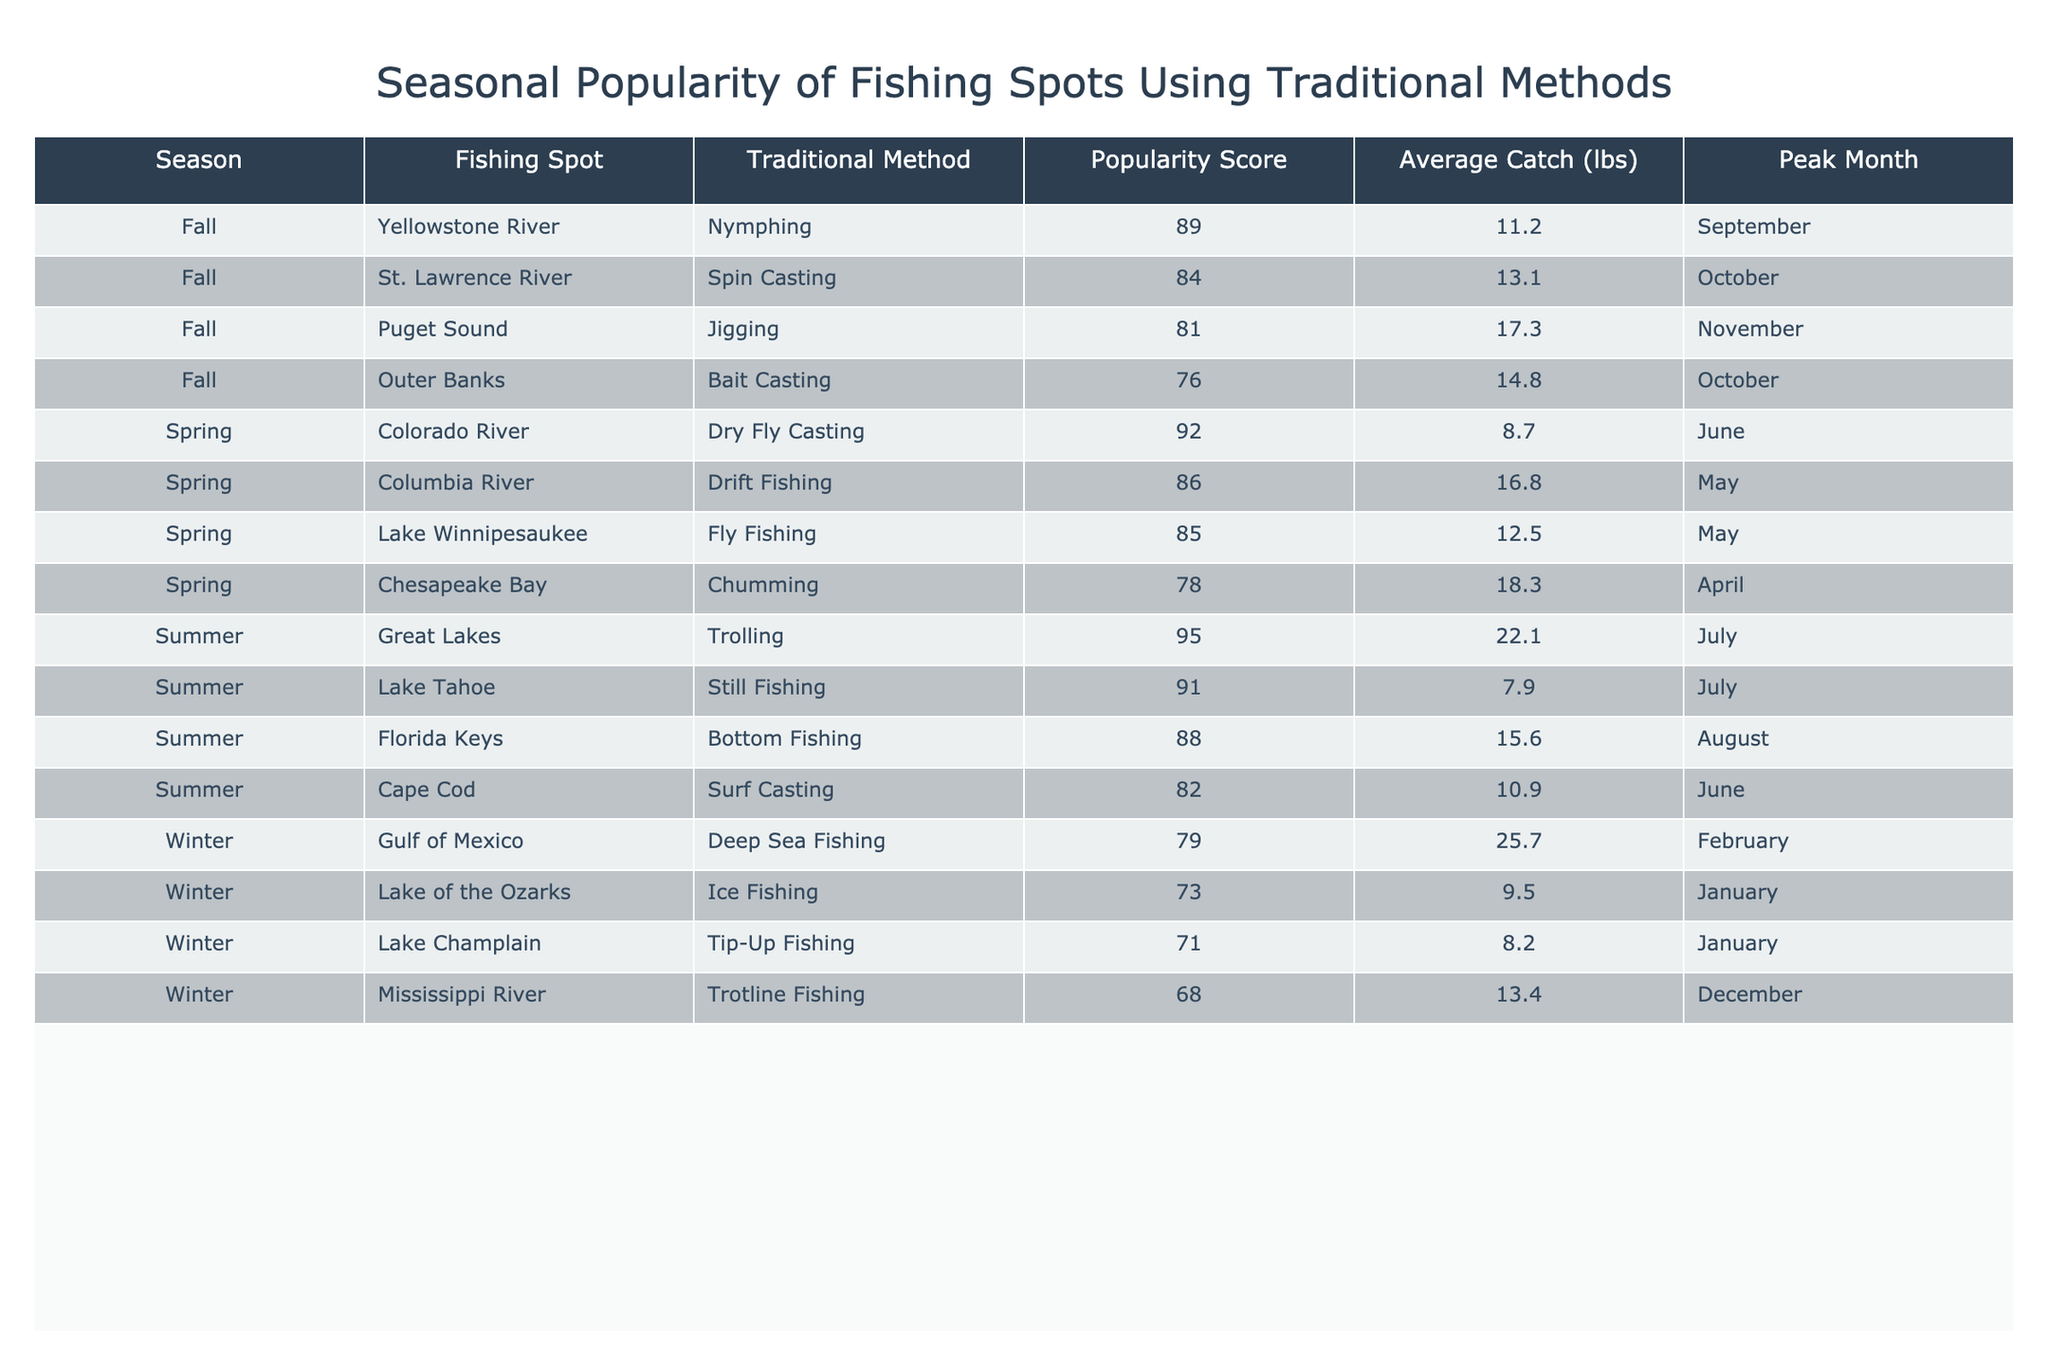What fishing spot has the highest popularity score in the summer? Looking at the summer season in the table, Great Lakes has the highest popularity score of 95.
Answer: Great Lakes What is the average catch weight for Ice Fishing? The average catch weight for Ice Fishing, conducted at Lake of the Ozarks in winter, is 9.5 lbs.
Answer: 9.5 lbs Which traditional fishing method has the lowest popularity score? In the table, Trotline Fishing has the lowest popularity score of 68, which is located in the winter season at the Mississippi River.
Answer: Trotline Fishing What is the total popularity score for fishing spots in the fall? Adding the popularity scores for the fall season spots gives us 89 + 76 + 81 = 246.
Answer: 246 Is Surf Casting more popular than Bottom Fishing in the summer? Comparing their scores, Surf Casting has a popularity score of 82, while Bottom Fishing has a score of 88; therefore, Bottom Fishing is more popular.
Answer: No What is the most popular traditional method in the spring? The method with the highest popularity score in the spring is Dry Fly Casting, scoring 92, located in the Colorado River.
Answer: Dry Fly Casting How many fishing spots have a popularity score of 80 or above? By reviewing the table, the spots with popularity scores of 80 or above are 7: Lake Winnipesaukee, Colorado River, Columbia River, Great Lakes, Florida Keys, Yellowstone River, and Lake Tahoe.
Answer: 7 Which month is the peak for fishing in the Great Lakes? The table shows that the peak month for fishing in the Great Lakes, which practices Trolling, is July.
Answer: July Which fishing method averages the highest catch weight? The fishing method with the highest average catch weight is Deep Sea Fishing with 25.7 lbs in the Gulf of Mexico during winter.
Answer: Deep Sea Fishing What is the difference in popularity score between the best and worst fishing methods in autumn? In autumn, the best method is Nymphing (89) and the worst is Bait Casting (76), so the difference is 89 - 76 = 13.
Answer: 13 